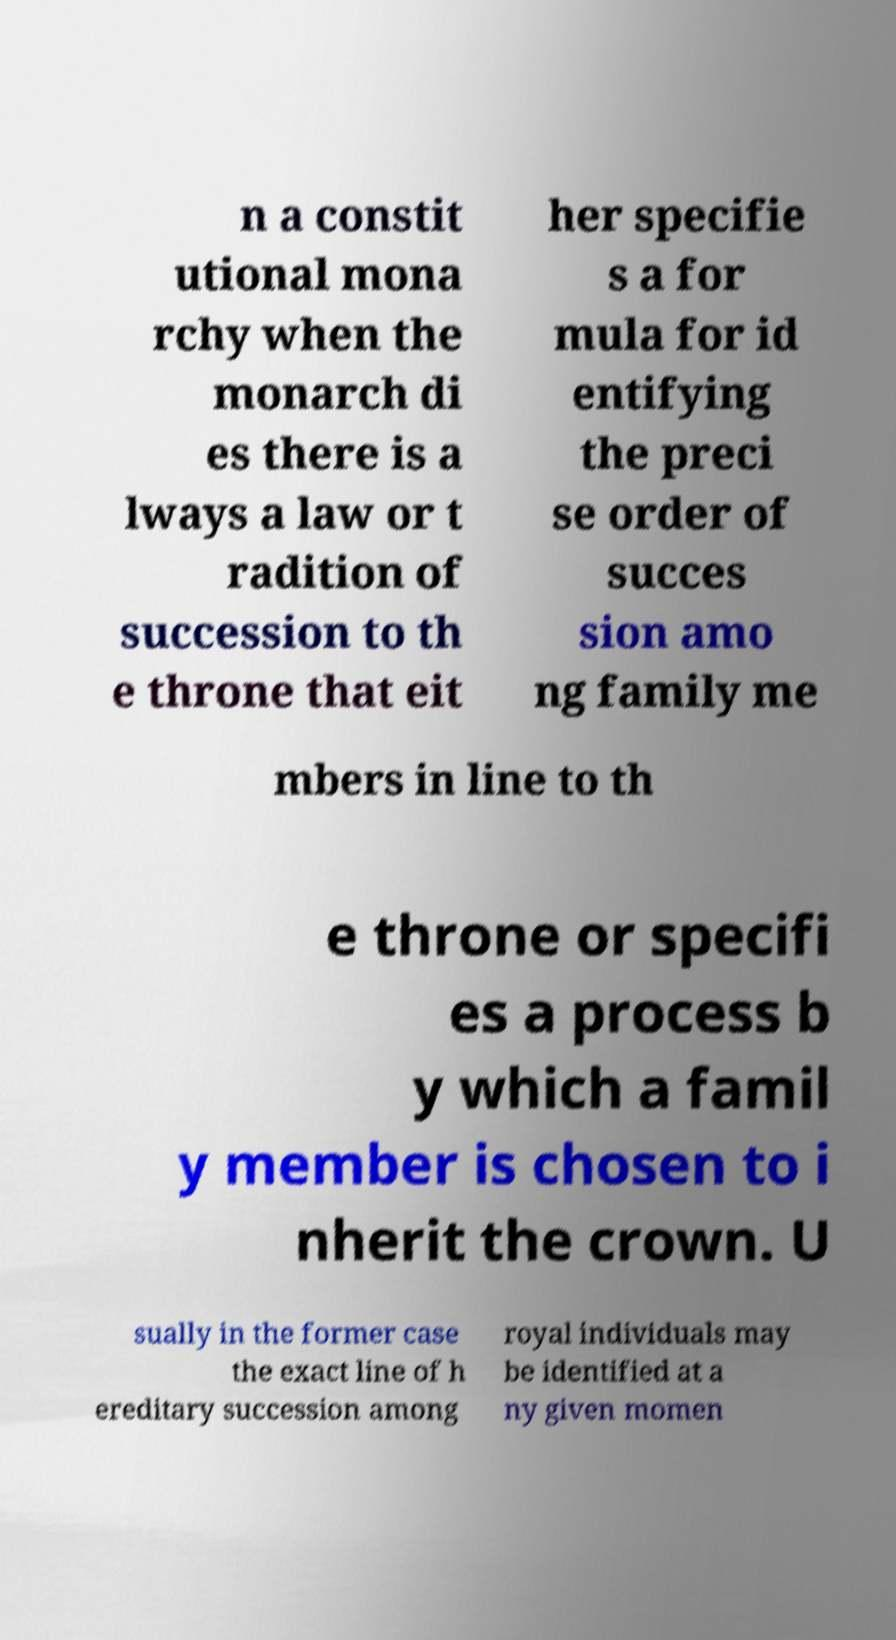Please identify and transcribe the text found in this image. n a constit utional mona rchy when the monarch di es there is a lways a law or t radition of succession to th e throne that eit her specifie s a for mula for id entifying the preci se order of succes sion amo ng family me mbers in line to th e throne or specifi es a process b y which a famil y member is chosen to i nherit the crown. U sually in the former case the exact line of h ereditary succession among royal individuals may be identified at a ny given momen 